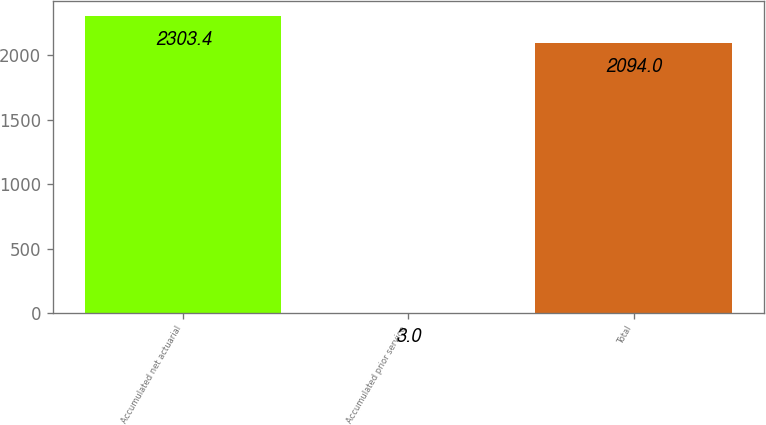Convert chart. <chart><loc_0><loc_0><loc_500><loc_500><bar_chart><fcel>Accumulated net actuarial<fcel>Accumulated prior service<fcel>Total<nl><fcel>2303.4<fcel>3<fcel>2094<nl></chart> 